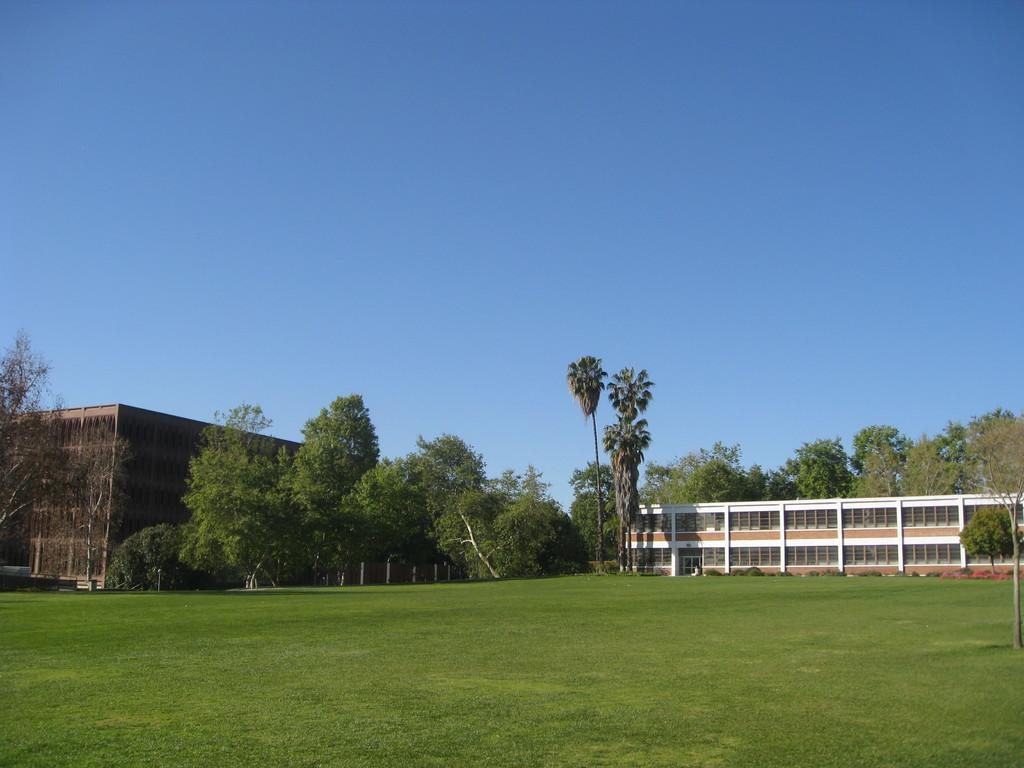What type of ground surface is visible in the image? There is grass on the ground in the image. What can be seen in the distance behind the grass? There are trees and buildings in the background of the image. What is visible above the trees and buildings? The sky is visible in the image. What type of toys are being distributed in the image? There are no toys present in the image. 